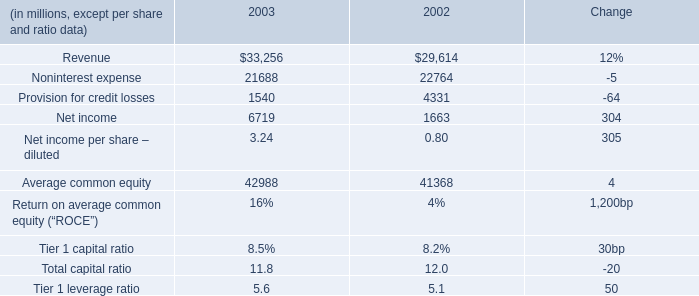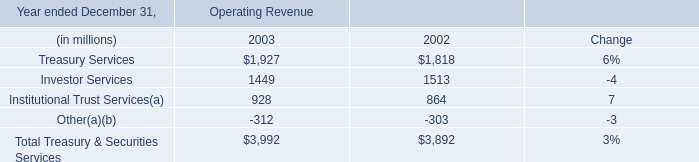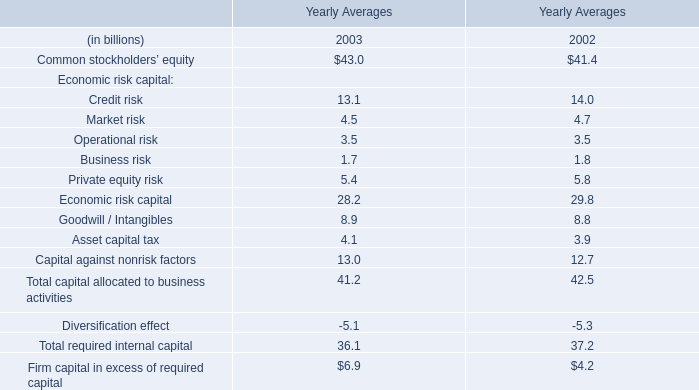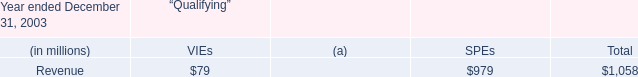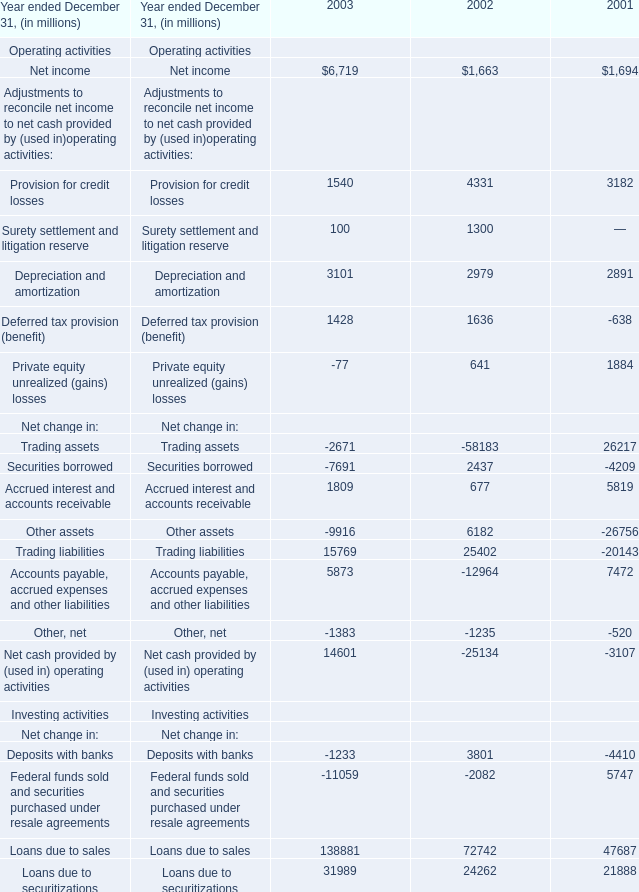Does Net income keeps increasing each year between 2003 and 2002? 
Answer: Yes. 